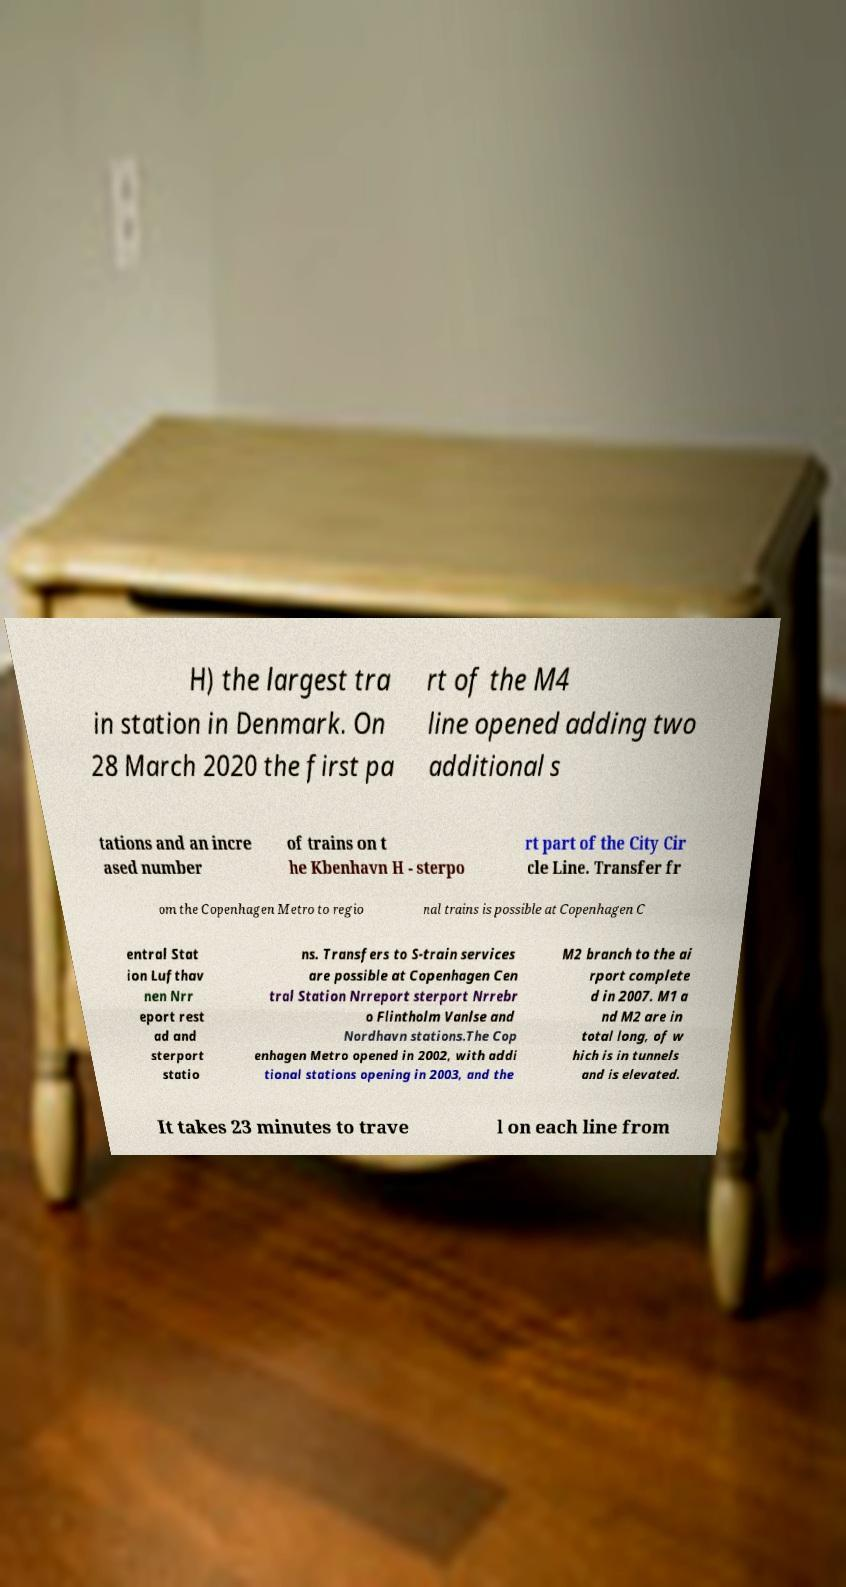Can you accurately transcribe the text from the provided image for me? H) the largest tra in station in Denmark. On 28 March 2020 the first pa rt of the M4 line opened adding two additional s tations and an incre ased number of trains on t he Kbenhavn H - sterpo rt part of the City Cir cle Line. Transfer fr om the Copenhagen Metro to regio nal trains is possible at Copenhagen C entral Stat ion Lufthav nen Nrr eport rest ad and sterport statio ns. Transfers to S-train services are possible at Copenhagen Cen tral Station Nrreport sterport Nrrebr o Flintholm Vanlse and Nordhavn stations.The Cop enhagen Metro opened in 2002, with addi tional stations opening in 2003, and the M2 branch to the ai rport complete d in 2007. M1 a nd M2 are in total long, of w hich is in tunnels and is elevated. It takes 23 minutes to trave l on each line from 